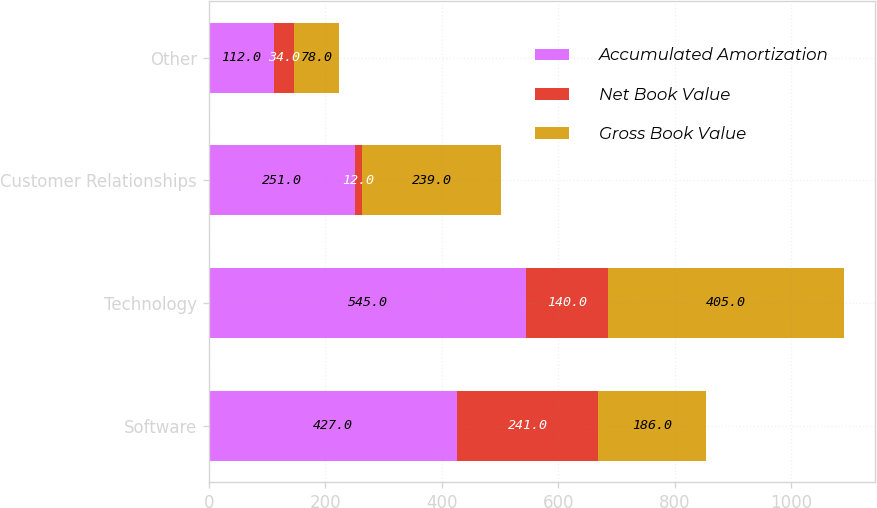<chart> <loc_0><loc_0><loc_500><loc_500><stacked_bar_chart><ecel><fcel>Software<fcel>Technology<fcel>Customer Relationships<fcel>Other<nl><fcel>Accumulated Amortization<fcel>427<fcel>545<fcel>251<fcel>112<nl><fcel>Net Book Value<fcel>241<fcel>140<fcel>12<fcel>34<nl><fcel>Gross Book Value<fcel>186<fcel>405<fcel>239<fcel>78<nl></chart> 